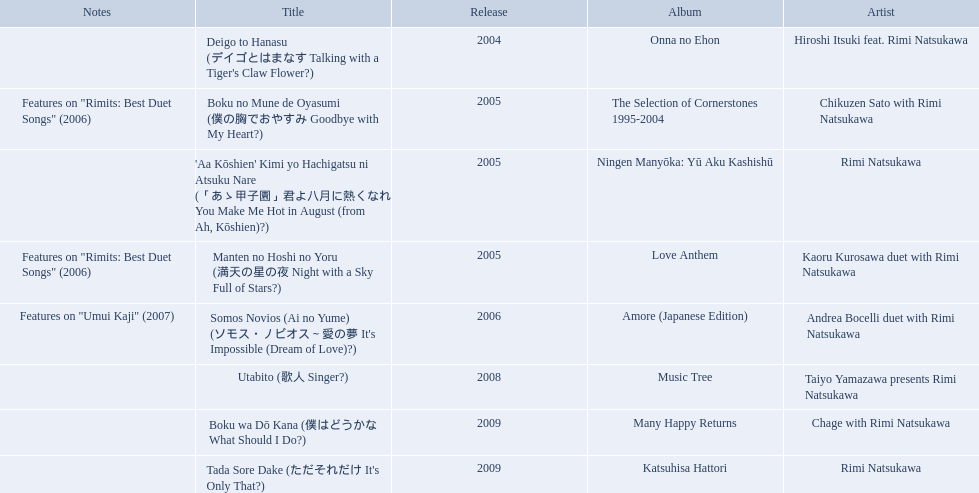What are the notes for sky full of stars? Features on "Rimits: Best Duet Songs" (2006). What other song features this same note? Boku no Mune de Oyasumi (僕の胸でおやすみ Goodbye with My Heart?). When was onna no ehon released? 2004. When was the selection of cornerstones 1995-2004 released? 2005. What was released in 2008? Music Tree. 